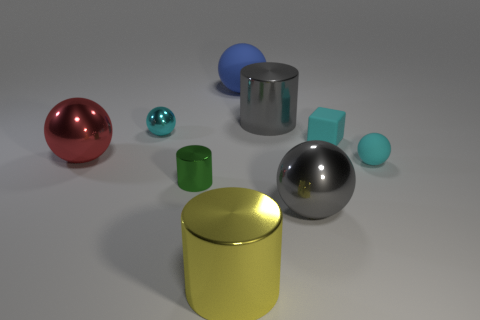Subtract all gray balls. How many balls are left? 4 Subtract all brown cubes. How many cyan spheres are left? 2 Subtract all yellow cylinders. How many cylinders are left? 2 Subtract all balls. How many objects are left? 4 Subtract 1 spheres. How many spheres are left? 4 Add 7 purple metal objects. How many purple metal objects exist? 7 Subtract 0 gray blocks. How many objects are left? 9 Subtract all brown blocks. Subtract all purple cylinders. How many blocks are left? 1 Subtract all tiny green objects. Subtract all big matte things. How many objects are left? 7 Add 3 large red balls. How many large red balls are left? 4 